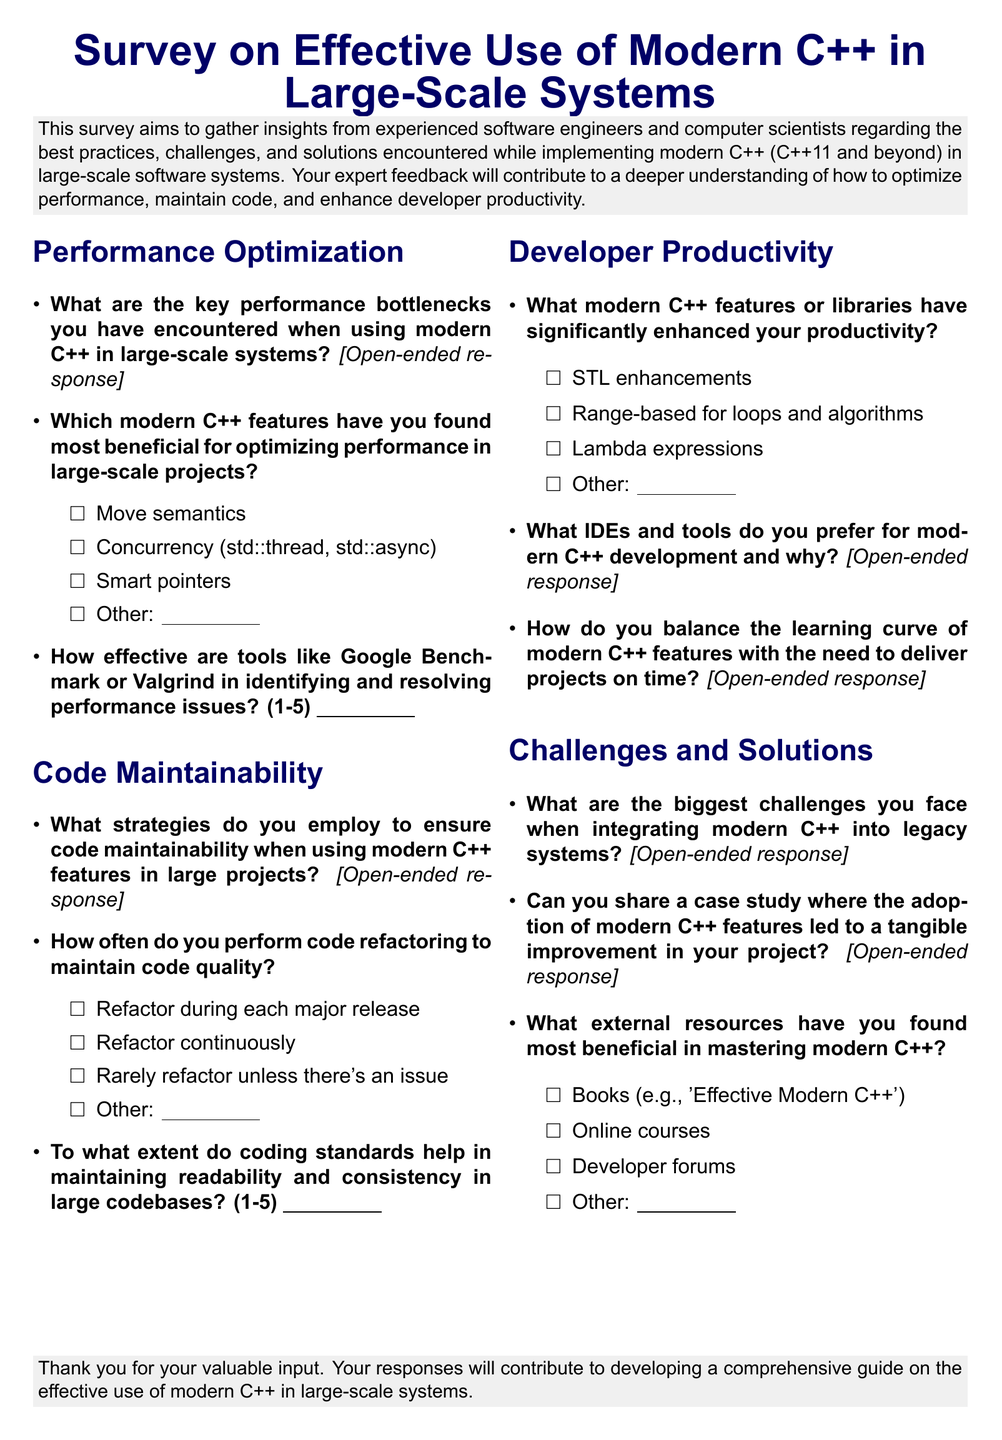What is the title of the survey? The title of the survey appears at the top of the document, indicating the focus of the inquiry.
Answer: Survey on Effective Use of Modern C++ in Large-Scale Systems How many sections are there in the survey? The document includes specific sections that categorize questions relevant to the topic, making it easier to navigate.
Answer: Four Which modern C++ feature is listed as an option for performance optimization? The document provides a list of specific features related to performance optimization.
Answer: Move semantics What is the scale used to rate the effectiveness of tools like Google Benchmark? The document provides a numerical scale format for assessing effectiveness, making responses quantifiable.
Answer: 1-5 In what context does the survey seek to understand modern C++ usage? The opening paragraph outlines the goals and focus areas of the survey, setting expectations for the respondents.
Answer: Large-scale software systems What type of response is solicited for strategies to ensure code maintainability? The survey format specifies the expected type of response from participants for some questions, indicating flexibility in answers.
Answer: Open-ended response 